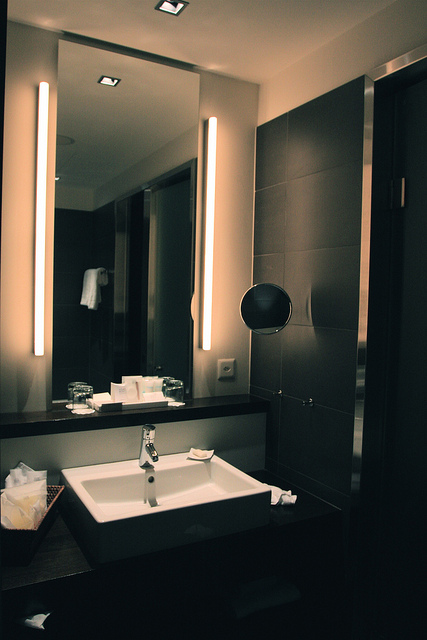What is the position of the wall socket? The wall socket can be found on the right side of the image, slightly above the middle of the wall, placed conveniently for use near the sink. 